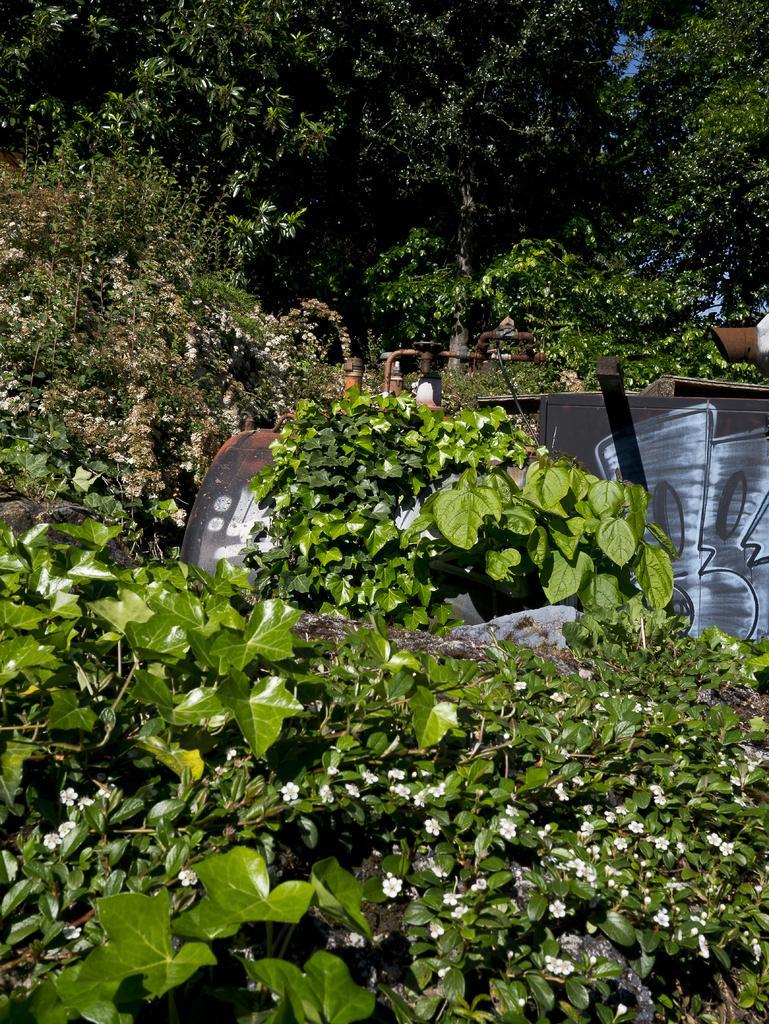Describe this image in one or two sentences. In this image I can see few green leaves and few trees. I can see a black and brown color object. 